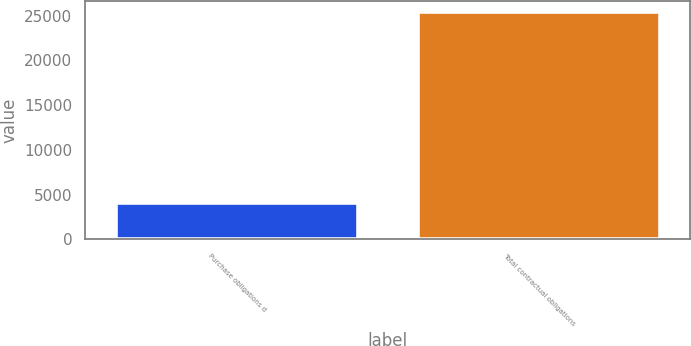Convert chart to OTSL. <chart><loc_0><loc_0><loc_500><loc_500><bar_chart><fcel>Purchase obligations d<fcel>Total contractual obligations<nl><fcel>4122<fcel>25387<nl></chart> 